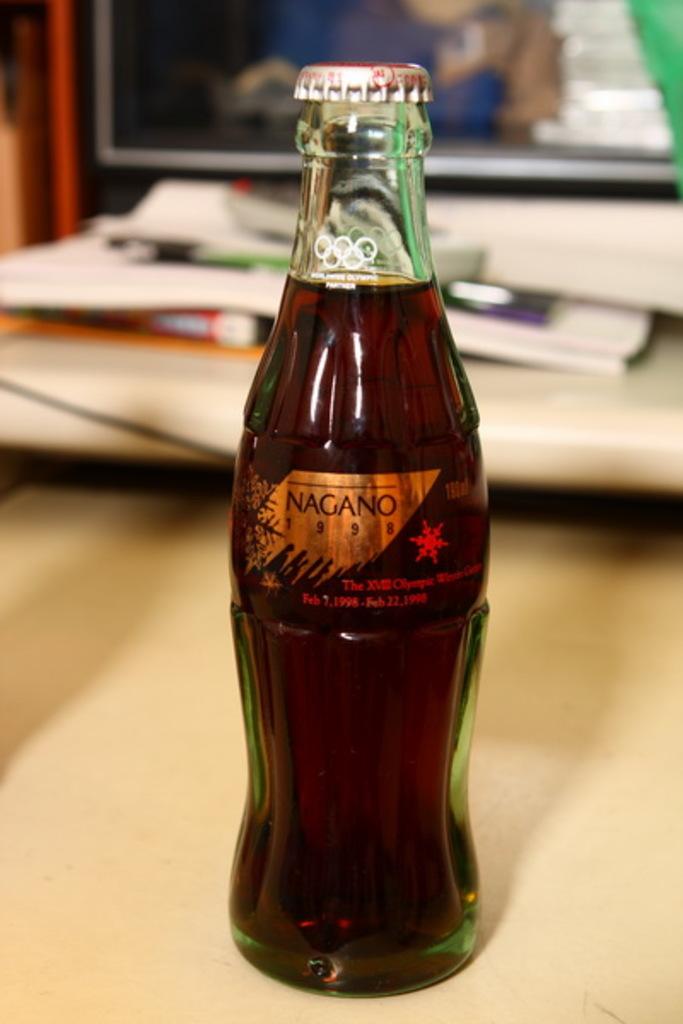What year is on the bottle?
Provide a short and direct response. 1998. 